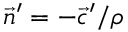Convert formula to latex. <formula><loc_0><loc_0><loc_500><loc_500>\, { \vec { n } } ^ { \prime } = - { \vec { c } } ^ { \prime } / \rho</formula> 